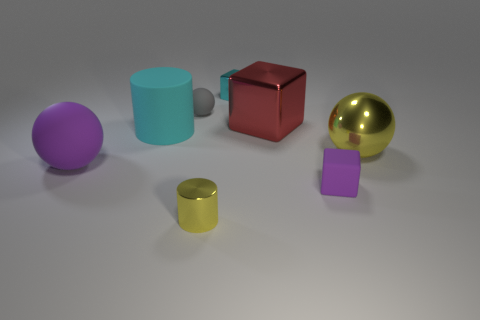Subtract all rubber balls. How many balls are left? 1 Add 2 purple blocks. How many objects exist? 10 Subtract all purple blocks. How many blocks are left? 2 Subtract 1 blocks. How many blocks are left? 2 Subtract all blocks. How many objects are left? 5 Subtract all green blocks. How many brown cylinders are left? 0 Subtract 0 blue spheres. How many objects are left? 8 Subtract all brown cubes. Subtract all yellow cylinders. How many cubes are left? 3 Subtract all large yellow objects. Subtract all yellow metal spheres. How many objects are left? 6 Add 5 shiny spheres. How many shiny spheres are left? 6 